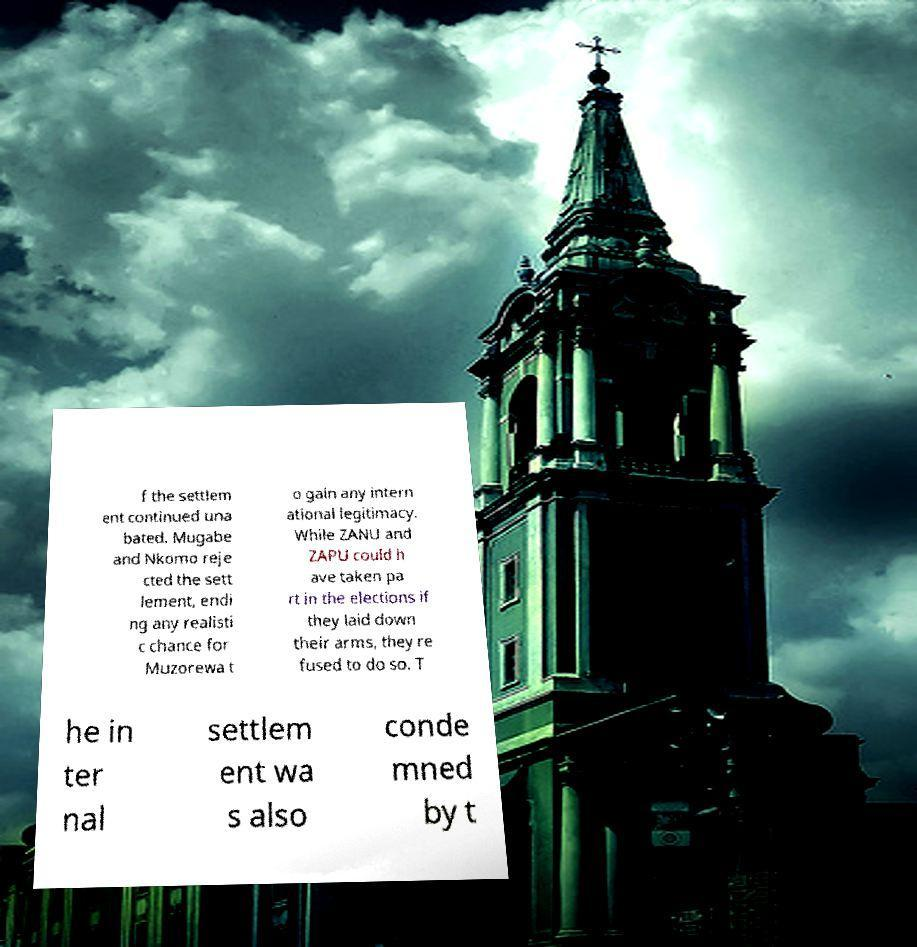Can you accurately transcribe the text from the provided image for me? f the settlem ent continued una bated. Mugabe and Nkomo reje cted the sett lement, endi ng any realisti c chance for Muzorewa t o gain any intern ational legitimacy. While ZANU and ZAPU could h ave taken pa rt in the elections if they laid down their arms, they re fused to do so. T he in ter nal settlem ent wa s also conde mned by t 